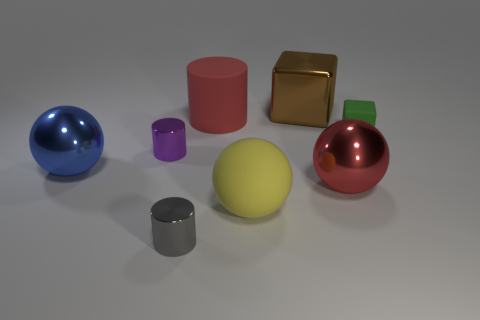What material is the large thing that is the same color as the large matte cylinder?
Provide a succinct answer. Metal. What number of metallic objects are small cylinders or purple things?
Keep it short and to the point. 2. What is the shape of the yellow thing?
Your response must be concise. Sphere. How many cylinders have the same material as the green object?
Provide a short and direct response. 1. What color is the cube that is the same material as the big blue object?
Make the answer very short. Brown. Is the size of the metal ball to the left of the gray cylinder the same as the big brown metallic object?
Provide a short and direct response. Yes. What color is the other metal thing that is the same shape as the green thing?
Your answer should be very brief. Brown. What shape is the rubber object behind the small thing that is on the right side of the cube that is behind the small rubber cube?
Ensure brevity in your answer.  Cylinder. Is the big blue shiny object the same shape as the large red metal object?
Ensure brevity in your answer.  Yes. What is the shape of the big red object that is left of the matte thing in front of the tiny green block?
Your response must be concise. Cylinder. 